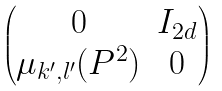Convert formula to latex. <formula><loc_0><loc_0><loc_500><loc_500>\begin{pmatrix} 0 & I _ { 2 d } \\ \mu _ { k ^ { \prime } , l ^ { \prime } } ( P ^ { 2 } ) & 0 \end{pmatrix}</formula> 